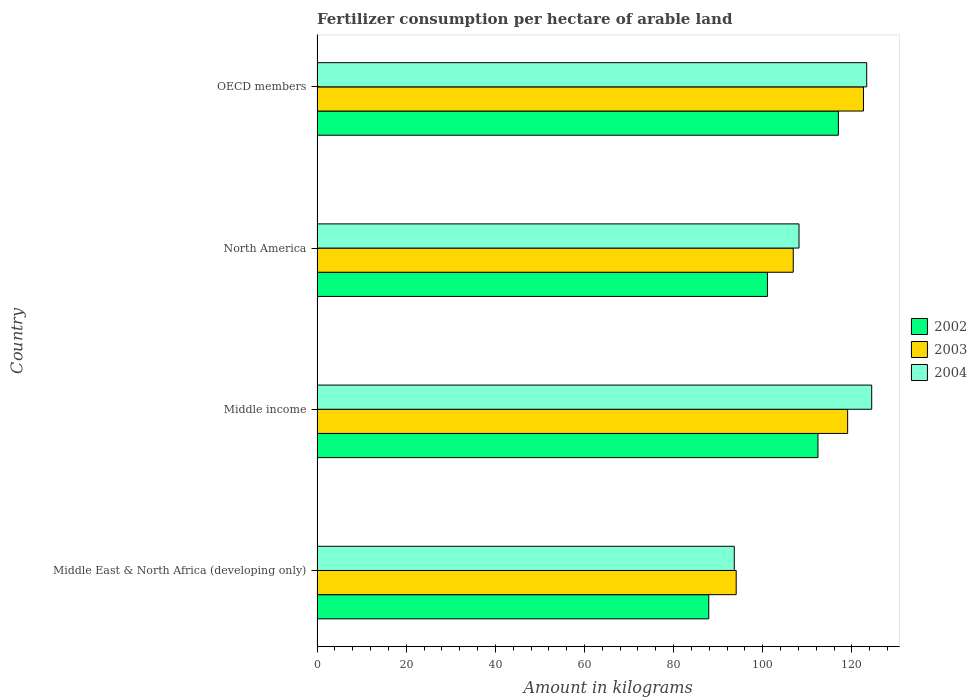How many different coloured bars are there?
Your answer should be very brief. 3. How many groups of bars are there?
Make the answer very short. 4. Are the number of bars per tick equal to the number of legend labels?
Offer a terse response. Yes. How many bars are there on the 2nd tick from the bottom?
Your response must be concise. 3. What is the label of the 4th group of bars from the top?
Your answer should be very brief. Middle East & North Africa (developing only). In how many cases, is the number of bars for a given country not equal to the number of legend labels?
Give a very brief answer. 0. What is the amount of fertilizer consumption in 2002 in Middle income?
Offer a very short reply. 112.38. Across all countries, what is the maximum amount of fertilizer consumption in 2004?
Your answer should be very brief. 124.44. Across all countries, what is the minimum amount of fertilizer consumption in 2002?
Give a very brief answer. 87.88. In which country was the amount of fertilizer consumption in 2003 maximum?
Make the answer very short. OECD members. In which country was the amount of fertilizer consumption in 2002 minimum?
Give a very brief answer. Middle East & North Africa (developing only). What is the total amount of fertilizer consumption in 2002 in the graph?
Your answer should be very brief. 418.27. What is the difference between the amount of fertilizer consumption in 2004 in Middle East & North Africa (developing only) and that in Middle income?
Give a very brief answer. -30.83. What is the difference between the amount of fertilizer consumption in 2004 in Middle income and the amount of fertilizer consumption in 2002 in Middle East & North Africa (developing only)?
Make the answer very short. 36.55. What is the average amount of fertilizer consumption in 2004 per country?
Your answer should be compact. 112.37. What is the difference between the amount of fertilizer consumption in 2002 and amount of fertilizer consumption in 2003 in Middle income?
Ensure brevity in your answer.  -6.66. In how many countries, is the amount of fertilizer consumption in 2002 greater than 124 kg?
Give a very brief answer. 0. What is the ratio of the amount of fertilizer consumption in 2003 in Middle income to that in OECD members?
Provide a succinct answer. 0.97. Is the amount of fertilizer consumption in 2002 in North America less than that in OECD members?
Keep it short and to the point. Yes. What is the difference between the highest and the second highest amount of fertilizer consumption in 2004?
Make the answer very short. 1.12. What is the difference between the highest and the lowest amount of fertilizer consumption in 2002?
Your response must be concise. 29.08. In how many countries, is the amount of fertilizer consumption in 2004 greater than the average amount of fertilizer consumption in 2004 taken over all countries?
Provide a short and direct response. 2. Is the sum of the amount of fertilizer consumption in 2002 in Middle East & North Africa (developing only) and North America greater than the maximum amount of fertilizer consumption in 2003 across all countries?
Offer a terse response. Yes. How many bars are there?
Provide a short and direct response. 12. How many countries are there in the graph?
Keep it short and to the point. 4. What is the difference between two consecutive major ticks on the X-axis?
Your answer should be very brief. 20. Are the values on the major ticks of X-axis written in scientific E-notation?
Ensure brevity in your answer.  No. Does the graph contain any zero values?
Ensure brevity in your answer.  No. How are the legend labels stacked?
Ensure brevity in your answer.  Vertical. What is the title of the graph?
Make the answer very short. Fertilizer consumption per hectare of arable land. Does "2004" appear as one of the legend labels in the graph?
Your response must be concise. Yes. What is the label or title of the X-axis?
Your answer should be very brief. Amount in kilograms. What is the label or title of the Y-axis?
Ensure brevity in your answer.  Country. What is the Amount in kilograms in 2002 in Middle East & North Africa (developing only)?
Keep it short and to the point. 87.88. What is the Amount in kilograms in 2003 in Middle East & North Africa (developing only)?
Provide a succinct answer. 94.04. What is the Amount in kilograms of 2004 in Middle East & North Africa (developing only)?
Keep it short and to the point. 93.61. What is the Amount in kilograms of 2002 in Middle income?
Provide a succinct answer. 112.38. What is the Amount in kilograms in 2003 in Middle income?
Ensure brevity in your answer.  119.04. What is the Amount in kilograms in 2004 in Middle income?
Give a very brief answer. 124.44. What is the Amount in kilograms of 2002 in North America?
Keep it short and to the point. 101.04. What is the Amount in kilograms in 2003 in North America?
Provide a succinct answer. 106.84. What is the Amount in kilograms in 2004 in North America?
Your answer should be very brief. 108.13. What is the Amount in kilograms in 2002 in OECD members?
Your answer should be compact. 116.96. What is the Amount in kilograms in 2003 in OECD members?
Provide a succinct answer. 122.59. What is the Amount in kilograms of 2004 in OECD members?
Your answer should be compact. 123.32. Across all countries, what is the maximum Amount in kilograms of 2002?
Your answer should be compact. 116.96. Across all countries, what is the maximum Amount in kilograms in 2003?
Make the answer very short. 122.59. Across all countries, what is the maximum Amount in kilograms of 2004?
Ensure brevity in your answer.  124.44. Across all countries, what is the minimum Amount in kilograms in 2002?
Provide a short and direct response. 87.88. Across all countries, what is the minimum Amount in kilograms of 2003?
Ensure brevity in your answer.  94.04. Across all countries, what is the minimum Amount in kilograms in 2004?
Ensure brevity in your answer.  93.61. What is the total Amount in kilograms in 2002 in the graph?
Provide a succinct answer. 418.27. What is the total Amount in kilograms of 2003 in the graph?
Your response must be concise. 442.51. What is the total Amount in kilograms in 2004 in the graph?
Provide a short and direct response. 449.49. What is the difference between the Amount in kilograms in 2002 in Middle East & North Africa (developing only) and that in Middle income?
Keep it short and to the point. -24.5. What is the difference between the Amount in kilograms of 2003 in Middle East & North Africa (developing only) and that in Middle income?
Make the answer very short. -25. What is the difference between the Amount in kilograms in 2004 in Middle East & North Africa (developing only) and that in Middle income?
Give a very brief answer. -30.83. What is the difference between the Amount in kilograms in 2002 in Middle East & North Africa (developing only) and that in North America?
Make the answer very short. -13.16. What is the difference between the Amount in kilograms in 2003 in Middle East & North Africa (developing only) and that in North America?
Offer a very short reply. -12.8. What is the difference between the Amount in kilograms of 2004 in Middle East & North Africa (developing only) and that in North America?
Your answer should be compact. -14.52. What is the difference between the Amount in kilograms in 2002 in Middle East & North Africa (developing only) and that in OECD members?
Offer a very short reply. -29.08. What is the difference between the Amount in kilograms of 2003 in Middle East & North Africa (developing only) and that in OECD members?
Provide a succinct answer. -28.55. What is the difference between the Amount in kilograms of 2004 in Middle East & North Africa (developing only) and that in OECD members?
Keep it short and to the point. -29.71. What is the difference between the Amount in kilograms in 2002 in Middle income and that in North America?
Ensure brevity in your answer.  11.34. What is the difference between the Amount in kilograms in 2003 in Middle income and that in North America?
Your answer should be very brief. 12.2. What is the difference between the Amount in kilograms of 2004 in Middle income and that in North America?
Your answer should be compact. 16.31. What is the difference between the Amount in kilograms of 2002 in Middle income and that in OECD members?
Your answer should be very brief. -4.58. What is the difference between the Amount in kilograms of 2003 in Middle income and that in OECD members?
Offer a terse response. -3.55. What is the difference between the Amount in kilograms in 2004 in Middle income and that in OECD members?
Provide a succinct answer. 1.12. What is the difference between the Amount in kilograms in 2002 in North America and that in OECD members?
Give a very brief answer. -15.92. What is the difference between the Amount in kilograms in 2003 in North America and that in OECD members?
Provide a succinct answer. -15.75. What is the difference between the Amount in kilograms in 2004 in North America and that in OECD members?
Make the answer very short. -15.2. What is the difference between the Amount in kilograms of 2002 in Middle East & North Africa (developing only) and the Amount in kilograms of 2003 in Middle income?
Your answer should be compact. -31.16. What is the difference between the Amount in kilograms of 2002 in Middle East & North Africa (developing only) and the Amount in kilograms of 2004 in Middle income?
Offer a terse response. -36.55. What is the difference between the Amount in kilograms of 2003 in Middle East & North Africa (developing only) and the Amount in kilograms of 2004 in Middle income?
Your answer should be very brief. -30.4. What is the difference between the Amount in kilograms of 2002 in Middle East & North Africa (developing only) and the Amount in kilograms of 2003 in North America?
Keep it short and to the point. -18.95. What is the difference between the Amount in kilograms in 2002 in Middle East & North Africa (developing only) and the Amount in kilograms in 2004 in North America?
Keep it short and to the point. -20.24. What is the difference between the Amount in kilograms in 2003 in Middle East & North Africa (developing only) and the Amount in kilograms in 2004 in North America?
Ensure brevity in your answer.  -14.09. What is the difference between the Amount in kilograms of 2002 in Middle East & North Africa (developing only) and the Amount in kilograms of 2003 in OECD members?
Provide a short and direct response. -34.71. What is the difference between the Amount in kilograms in 2002 in Middle East & North Africa (developing only) and the Amount in kilograms in 2004 in OECD members?
Ensure brevity in your answer.  -35.44. What is the difference between the Amount in kilograms in 2003 in Middle East & North Africa (developing only) and the Amount in kilograms in 2004 in OECD members?
Your answer should be very brief. -29.29. What is the difference between the Amount in kilograms in 2002 in Middle income and the Amount in kilograms in 2003 in North America?
Your answer should be very brief. 5.54. What is the difference between the Amount in kilograms of 2002 in Middle income and the Amount in kilograms of 2004 in North America?
Your answer should be very brief. 4.26. What is the difference between the Amount in kilograms of 2003 in Middle income and the Amount in kilograms of 2004 in North America?
Provide a succinct answer. 10.91. What is the difference between the Amount in kilograms in 2002 in Middle income and the Amount in kilograms in 2003 in OECD members?
Provide a short and direct response. -10.21. What is the difference between the Amount in kilograms of 2002 in Middle income and the Amount in kilograms of 2004 in OECD members?
Your answer should be very brief. -10.94. What is the difference between the Amount in kilograms of 2003 in Middle income and the Amount in kilograms of 2004 in OECD members?
Offer a terse response. -4.28. What is the difference between the Amount in kilograms of 2002 in North America and the Amount in kilograms of 2003 in OECD members?
Provide a short and direct response. -21.55. What is the difference between the Amount in kilograms of 2002 in North America and the Amount in kilograms of 2004 in OECD members?
Give a very brief answer. -22.28. What is the difference between the Amount in kilograms in 2003 in North America and the Amount in kilograms in 2004 in OECD members?
Provide a short and direct response. -16.48. What is the average Amount in kilograms in 2002 per country?
Your response must be concise. 104.57. What is the average Amount in kilograms in 2003 per country?
Make the answer very short. 110.63. What is the average Amount in kilograms in 2004 per country?
Your answer should be compact. 112.37. What is the difference between the Amount in kilograms of 2002 and Amount in kilograms of 2003 in Middle East & North Africa (developing only)?
Your response must be concise. -6.15. What is the difference between the Amount in kilograms of 2002 and Amount in kilograms of 2004 in Middle East & North Africa (developing only)?
Your response must be concise. -5.72. What is the difference between the Amount in kilograms of 2003 and Amount in kilograms of 2004 in Middle East & North Africa (developing only)?
Ensure brevity in your answer.  0.43. What is the difference between the Amount in kilograms of 2002 and Amount in kilograms of 2003 in Middle income?
Give a very brief answer. -6.66. What is the difference between the Amount in kilograms in 2002 and Amount in kilograms in 2004 in Middle income?
Provide a succinct answer. -12.05. What is the difference between the Amount in kilograms of 2003 and Amount in kilograms of 2004 in Middle income?
Provide a short and direct response. -5.4. What is the difference between the Amount in kilograms of 2002 and Amount in kilograms of 2003 in North America?
Give a very brief answer. -5.8. What is the difference between the Amount in kilograms of 2002 and Amount in kilograms of 2004 in North America?
Make the answer very short. -7.09. What is the difference between the Amount in kilograms in 2003 and Amount in kilograms in 2004 in North America?
Provide a short and direct response. -1.29. What is the difference between the Amount in kilograms of 2002 and Amount in kilograms of 2003 in OECD members?
Your response must be concise. -5.63. What is the difference between the Amount in kilograms of 2002 and Amount in kilograms of 2004 in OECD members?
Your response must be concise. -6.36. What is the difference between the Amount in kilograms in 2003 and Amount in kilograms in 2004 in OECD members?
Provide a short and direct response. -0.73. What is the ratio of the Amount in kilograms in 2002 in Middle East & North Africa (developing only) to that in Middle income?
Give a very brief answer. 0.78. What is the ratio of the Amount in kilograms in 2003 in Middle East & North Africa (developing only) to that in Middle income?
Your response must be concise. 0.79. What is the ratio of the Amount in kilograms of 2004 in Middle East & North Africa (developing only) to that in Middle income?
Give a very brief answer. 0.75. What is the ratio of the Amount in kilograms of 2002 in Middle East & North Africa (developing only) to that in North America?
Your answer should be very brief. 0.87. What is the ratio of the Amount in kilograms of 2003 in Middle East & North Africa (developing only) to that in North America?
Your response must be concise. 0.88. What is the ratio of the Amount in kilograms of 2004 in Middle East & North Africa (developing only) to that in North America?
Your answer should be very brief. 0.87. What is the ratio of the Amount in kilograms of 2002 in Middle East & North Africa (developing only) to that in OECD members?
Provide a short and direct response. 0.75. What is the ratio of the Amount in kilograms in 2003 in Middle East & North Africa (developing only) to that in OECD members?
Give a very brief answer. 0.77. What is the ratio of the Amount in kilograms in 2004 in Middle East & North Africa (developing only) to that in OECD members?
Give a very brief answer. 0.76. What is the ratio of the Amount in kilograms of 2002 in Middle income to that in North America?
Give a very brief answer. 1.11. What is the ratio of the Amount in kilograms of 2003 in Middle income to that in North America?
Your answer should be compact. 1.11. What is the ratio of the Amount in kilograms of 2004 in Middle income to that in North America?
Ensure brevity in your answer.  1.15. What is the ratio of the Amount in kilograms of 2002 in Middle income to that in OECD members?
Your response must be concise. 0.96. What is the ratio of the Amount in kilograms of 2003 in Middle income to that in OECD members?
Offer a terse response. 0.97. What is the ratio of the Amount in kilograms of 2004 in Middle income to that in OECD members?
Keep it short and to the point. 1.01. What is the ratio of the Amount in kilograms in 2002 in North America to that in OECD members?
Your answer should be compact. 0.86. What is the ratio of the Amount in kilograms of 2003 in North America to that in OECD members?
Your answer should be compact. 0.87. What is the ratio of the Amount in kilograms of 2004 in North America to that in OECD members?
Make the answer very short. 0.88. What is the difference between the highest and the second highest Amount in kilograms in 2002?
Provide a succinct answer. 4.58. What is the difference between the highest and the second highest Amount in kilograms of 2003?
Ensure brevity in your answer.  3.55. What is the difference between the highest and the second highest Amount in kilograms in 2004?
Keep it short and to the point. 1.12. What is the difference between the highest and the lowest Amount in kilograms of 2002?
Make the answer very short. 29.08. What is the difference between the highest and the lowest Amount in kilograms in 2003?
Your response must be concise. 28.55. What is the difference between the highest and the lowest Amount in kilograms in 2004?
Give a very brief answer. 30.83. 